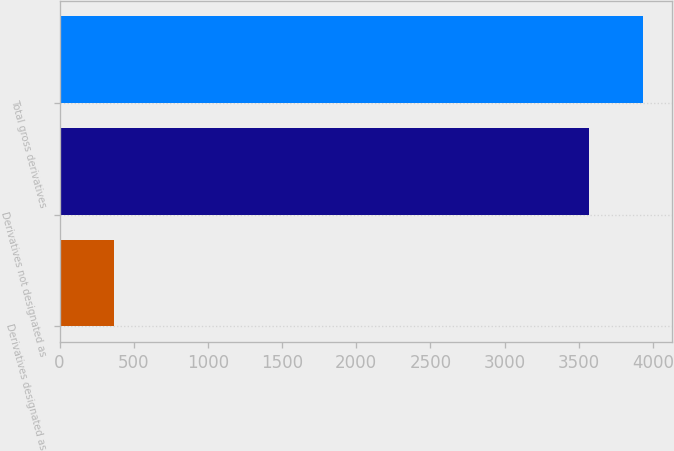<chart> <loc_0><loc_0><loc_500><loc_500><bar_chart><fcel>Derivatives designated as<fcel>Derivatives not designated as<fcel>Total gross derivatives<nl><fcel>364<fcel>3570<fcel>3934<nl></chart> 